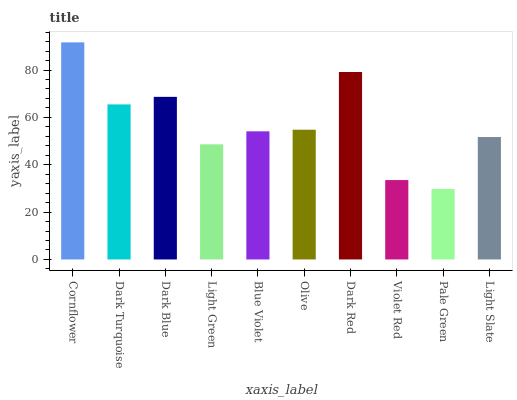Is Pale Green the minimum?
Answer yes or no. Yes. Is Cornflower the maximum?
Answer yes or no. Yes. Is Dark Turquoise the minimum?
Answer yes or no. No. Is Dark Turquoise the maximum?
Answer yes or no. No. Is Cornflower greater than Dark Turquoise?
Answer yes or no. Yes. Is Dark Turquoise less than Cornflower?
Answer yes or no. Yes. Is Dark Turquoise greater than Cornflower?
Answer yes or no. No. Is Cornflower less than Dark Turquoise?
Answer yes or no. No. Is Olive the high median?
Answer yes or no. Yes. Is Blue Violet the low median?
Answer yes or no. Yes. Is Dark Red the high median?
Answer yes or no. No. Is Dark Blue the low median?
Answer yes or no. No. 